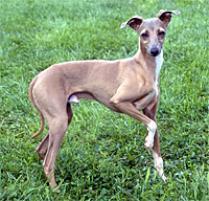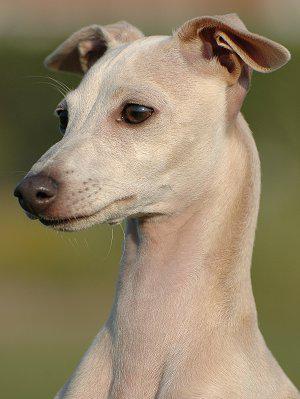The first image is the image on the left, the second image is the image on the right. Analyze the images presented: Is the assertion "In all photos, all four legs are visible." valid? Answer yes or no. No. 